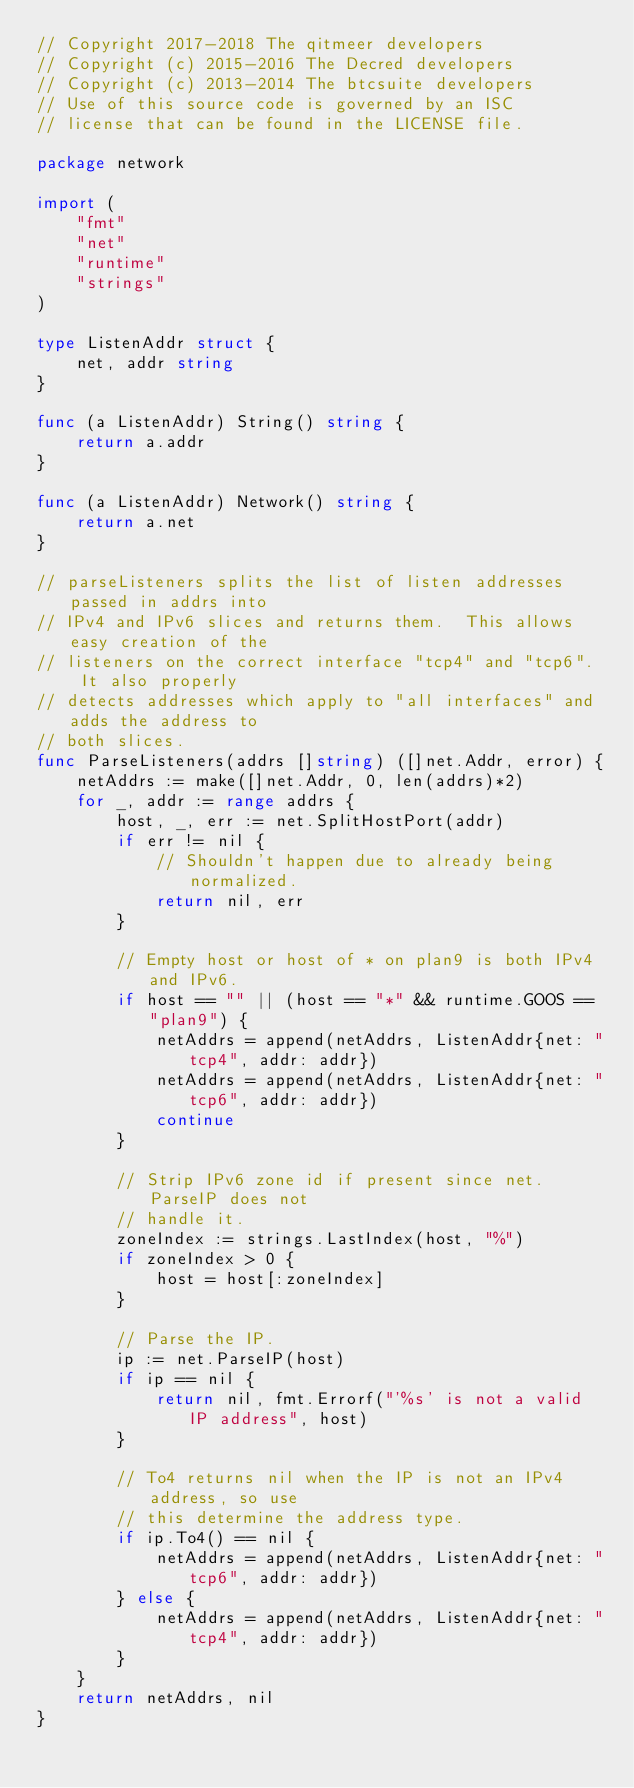Convert code to text. <code><loc_0><loc_0><loc_500><loc_500><_Go_>// Copyright 2017-2018 The qitmeer developers
// Copyright (c) 2015-2016 The Decred developers
// Copyright (c) 2013-2014 The btcsuite developers
// Use of this source code is governed by an ISC
// license that can be found in the LICENSE file.

package network

import (
	"fmt"
	"net"
	"runtime"
	"strings"
)

type ListenAddr struct {
	net, addr string
}

func (a ListenAddr) String() string {
	return a.addr
}

func (a ListenAddr) Network() string {
	return a.net
}

// parseListeners splits the list of listen addresses passed in addrs into
// IPv4 and IPv6 slices and returns them.  This allows easy creation of the
// listeners on the correct interface "tcp4" and "tcp6".  It also properly
// detects addresses which apply to "all interfaces" and adds the address to
// both slices.
func ParseListeners(addrs []string) ([]net.Addr, error) {
	netAddrs := make([]net.Addr, 0, len(addrs)*2)
	for _, addr := range addrs {
		host, _, err := net.SplitHostPort(addr)
		if err != nil {
			// Shouldn't happen due to already being normalized.
			return nil, err
		}

		// Empty host or host of * on plan9 is both IPv4 and IPv6.
		if host == "" || (host == "*" && runtime.GOOS == "plan9") {
			netAddrs = append(netAddrs, ListenAddr{net: "tcp4", addr: addr})
			netAddrs = append(netAddrs, ListenAddr{net: "tcp6", addr: addr})
			continue
		}

		// Strip IPv6 zone id if present since net.ParseIP does not
		// handle it.
		zoneIndex := strings.LastIndex(host, "%")
		if zoneIndex > 0 {
			host = host[:zoneIndex]
		}

		// Parse the IP.
		ip := net.ParseIP(host)
		if ip == nil {
			return nil, fmt.Errorf("'%s' is not a valid IP address", host)
		}

		// To4 returns nil when the IP is not an IPv4 address, so use
		// this determine the address type.
		if ip.To4() == nil {
			netAddrs = append(netAddrs, ListenAddr{net: "tcp6", addr: addr})
		} else {
			netAddrs = append(netAddrs, ListenAddr{net: "tcp4", addr: addr})
		}
	}
	return netAddrs, nil
}
</code> 